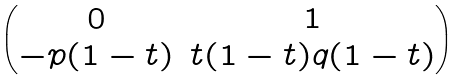<formula> <loc_0><loc_0><loc_500><loc_500>\begin{pmatrix} 0 & 1 \\ - p ( 1 - t ) & t ( 1 - t ) q ( 1 - t ) \end{pmatrix}</formula> 